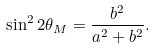Convert formula to latex. <formula><loc_0><loc_0><loc_500><loc_500>\sin ^ { 2 } 2 \theta _ { M } = \frac { b ^ { 2 } } { a ^ { 2 } + b ^ { 2 } } .</formula> 